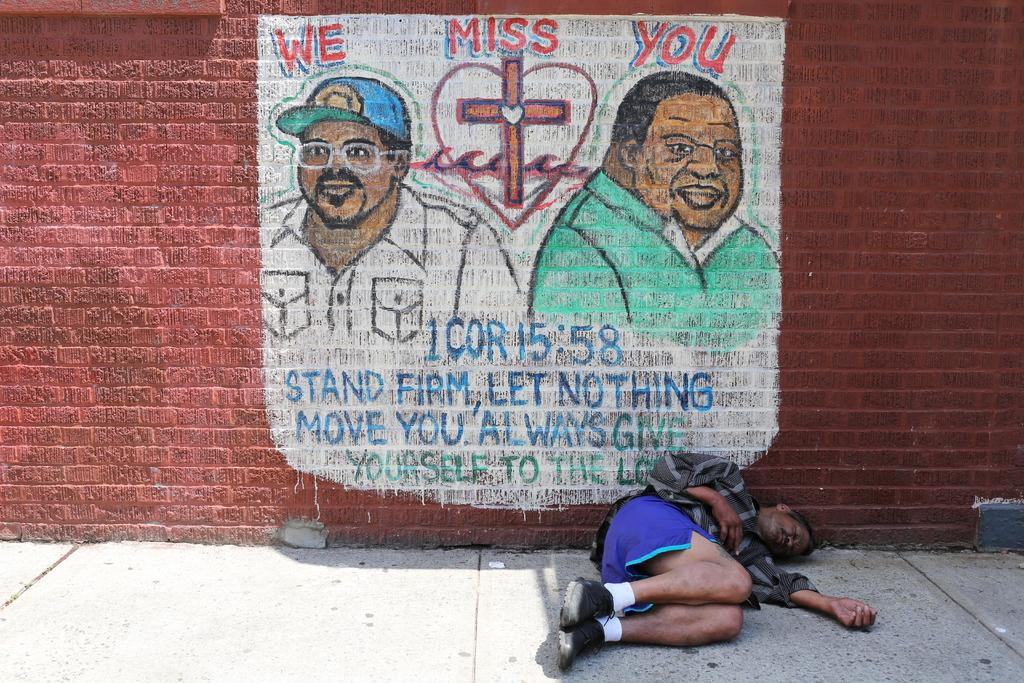<image>
Share a concise interpretation of the image provided. Person sleeping on the street in front of a wall which says We Miss You. 